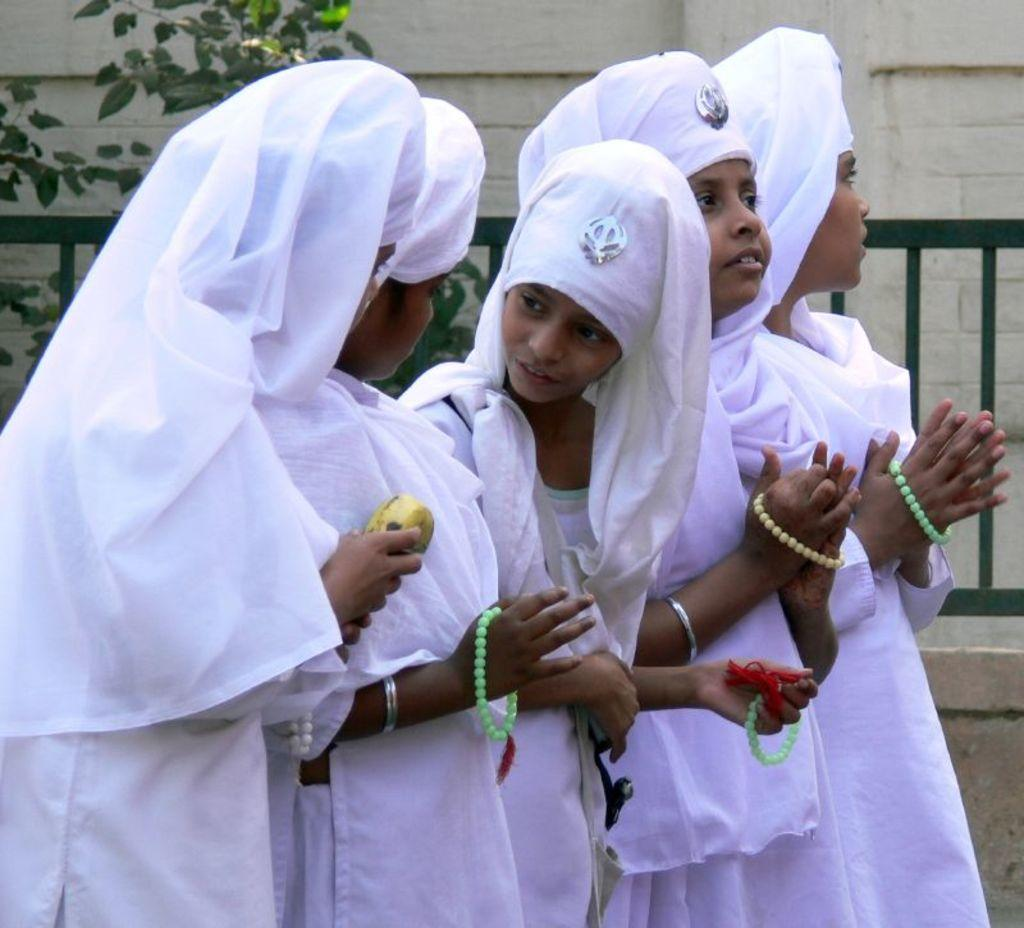What is the main subject of the image? The main subject of the image is a group of girls. What are the girls wearing? The girls are wearing traditional costumes. What can be seen in the background of the image? There is a plant, railing, and a wall in the background of the image. How many bears can be seen interacting with the girls in the image? There are no bears present in the image; it features a group of girls wearing traditional costumes with a background of a plant, railing, and wall. What type of sorting activity is taking place in the image? There is no sorting activity present in the image. 